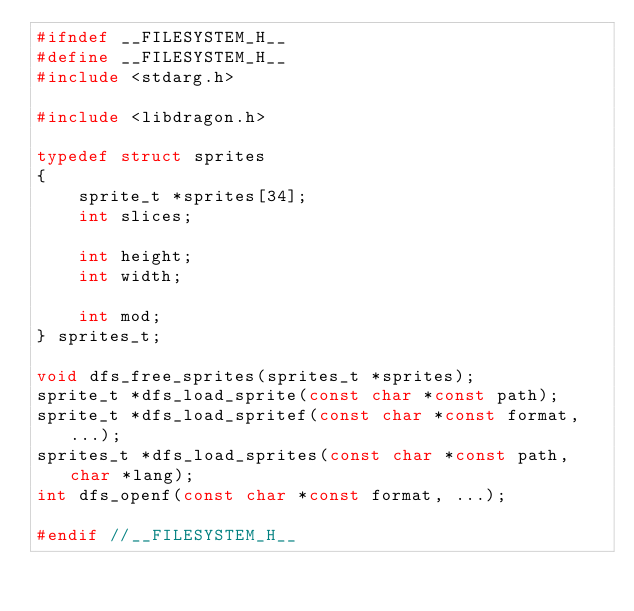Convert code to text. <code><loc_0><loc_0><loc_500><loc_500><_C_>#ifndef __FILESYSTEM_H__
#define __FILESYSTEM_H__
#include <stdarg.h>

#include <libdragon.h>

typedef struct sprites
{
    sprite_t *sprites[34];
    int slices;

    int height;
    int width;

    int mod;
} sprites_t;

void dfs_free_sprites(sprites_t *sprites);
sprite_t *dfs_load_sprite(const char *const path);
sprite_t *dfs_load_spritef(const char *const format, ...);
sprites_t *dfs_load_sprites(const char *const path, char *lang);
int dfs_openf(const char *const format, ...);

#endif //__FILESYSTEM_H__</code> 